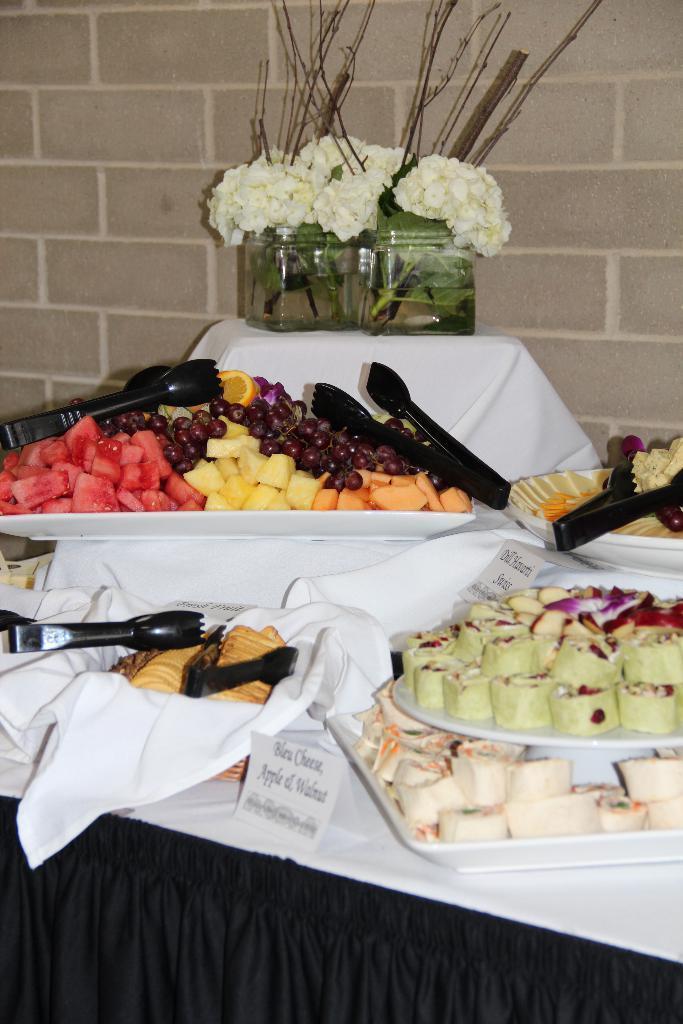Could you give a brief overview of what you see in this image? This picture contains a table which is covered with white and black color cloth. On the table, we see the plate containing sweets and a tray containing fruits and a name board. We even see flower vases are placed on that table. Behind that, we see a wall which is made up of bricks. 